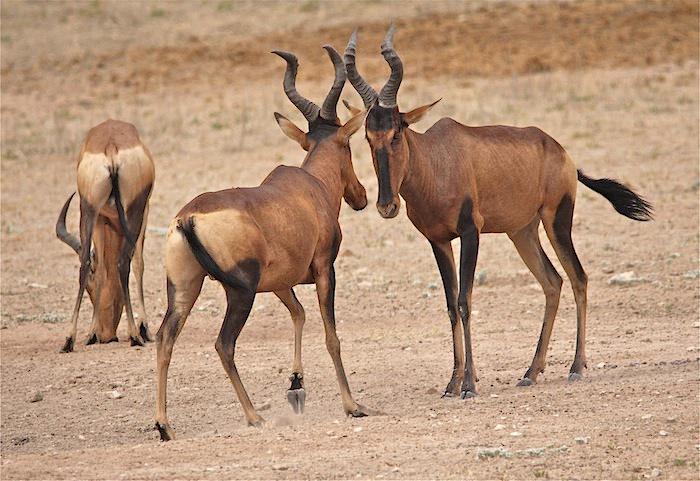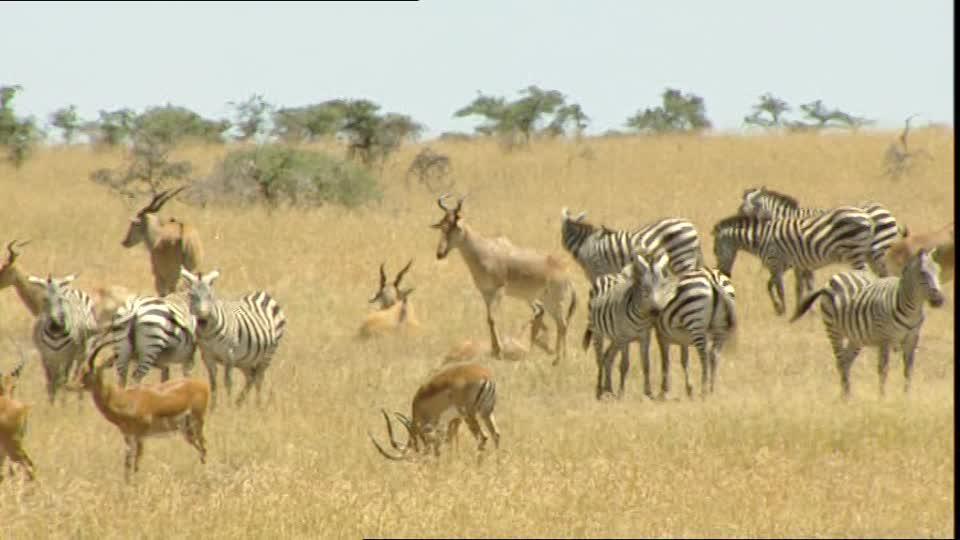The first image is the image on the left, the second image is the image on the right. Evaluate the accuracy of this statement regarding the images: "In one image, none of the horned animals are standing on the ground.". Is it true? Answer yes or no. No. The first image is the image on the left, the second image is the image on the right. Analyze the images presented: Is the assertion "At least one photo has two or fewer animals." valid? Answer yes or no. No. 